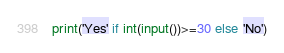<code> <loc_0><loc_0><loc_500><loc_500><_Python_>print('Yes' if int(input())>=30 else 'No')</code> 